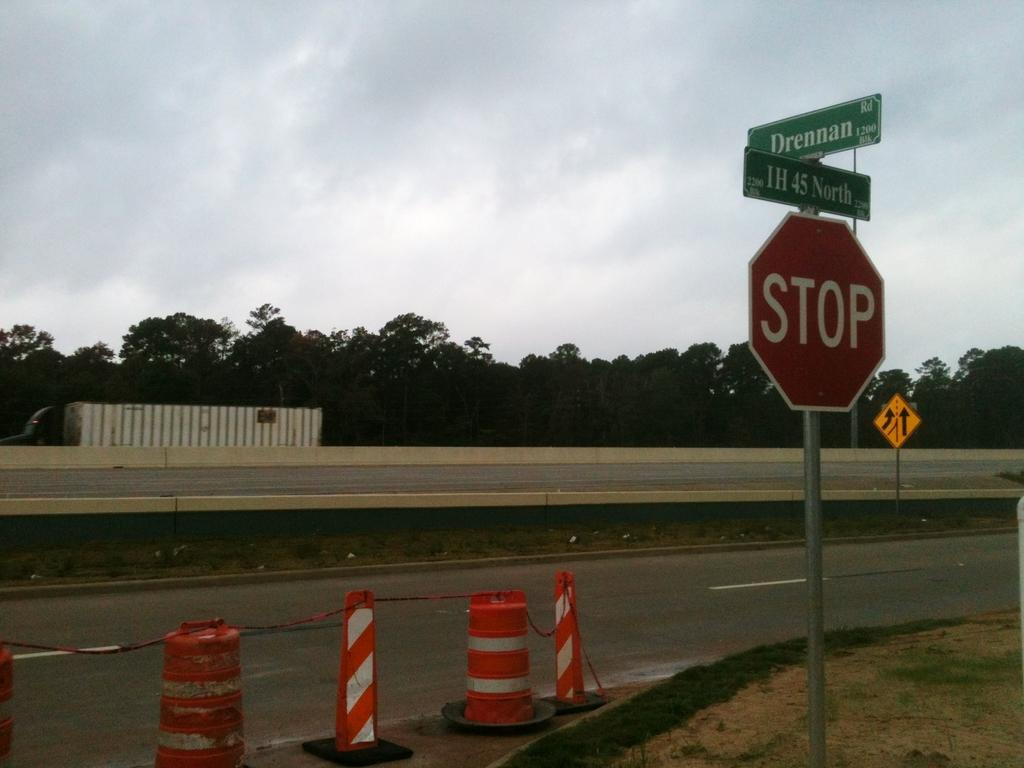<image>
Create a compact narrative representing the image presented. A street with a stop sign and two signs above it that say Drennan and IH 45 North. 